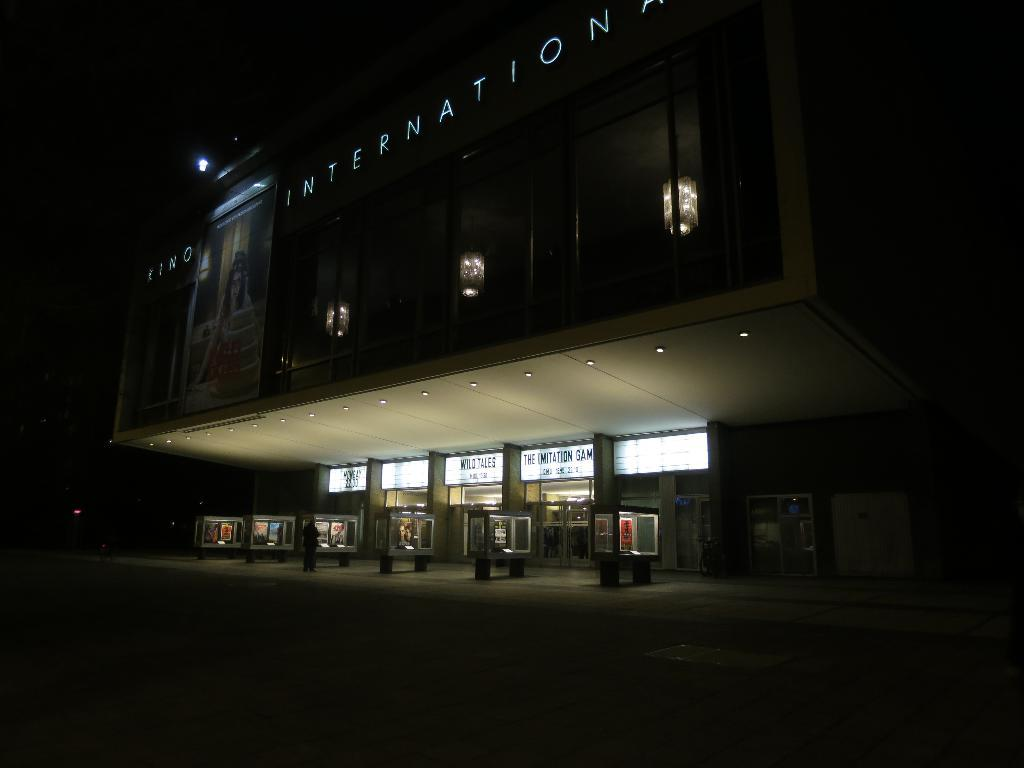What type of structure is visible in the image? There is a building in the image. What can be seen written on the building? The word "International" is written on the building. What type of apparatus is used by the tramp in the image? There is no tramp or apparatus present in the image; it only features a building with the word "International" written on it. 